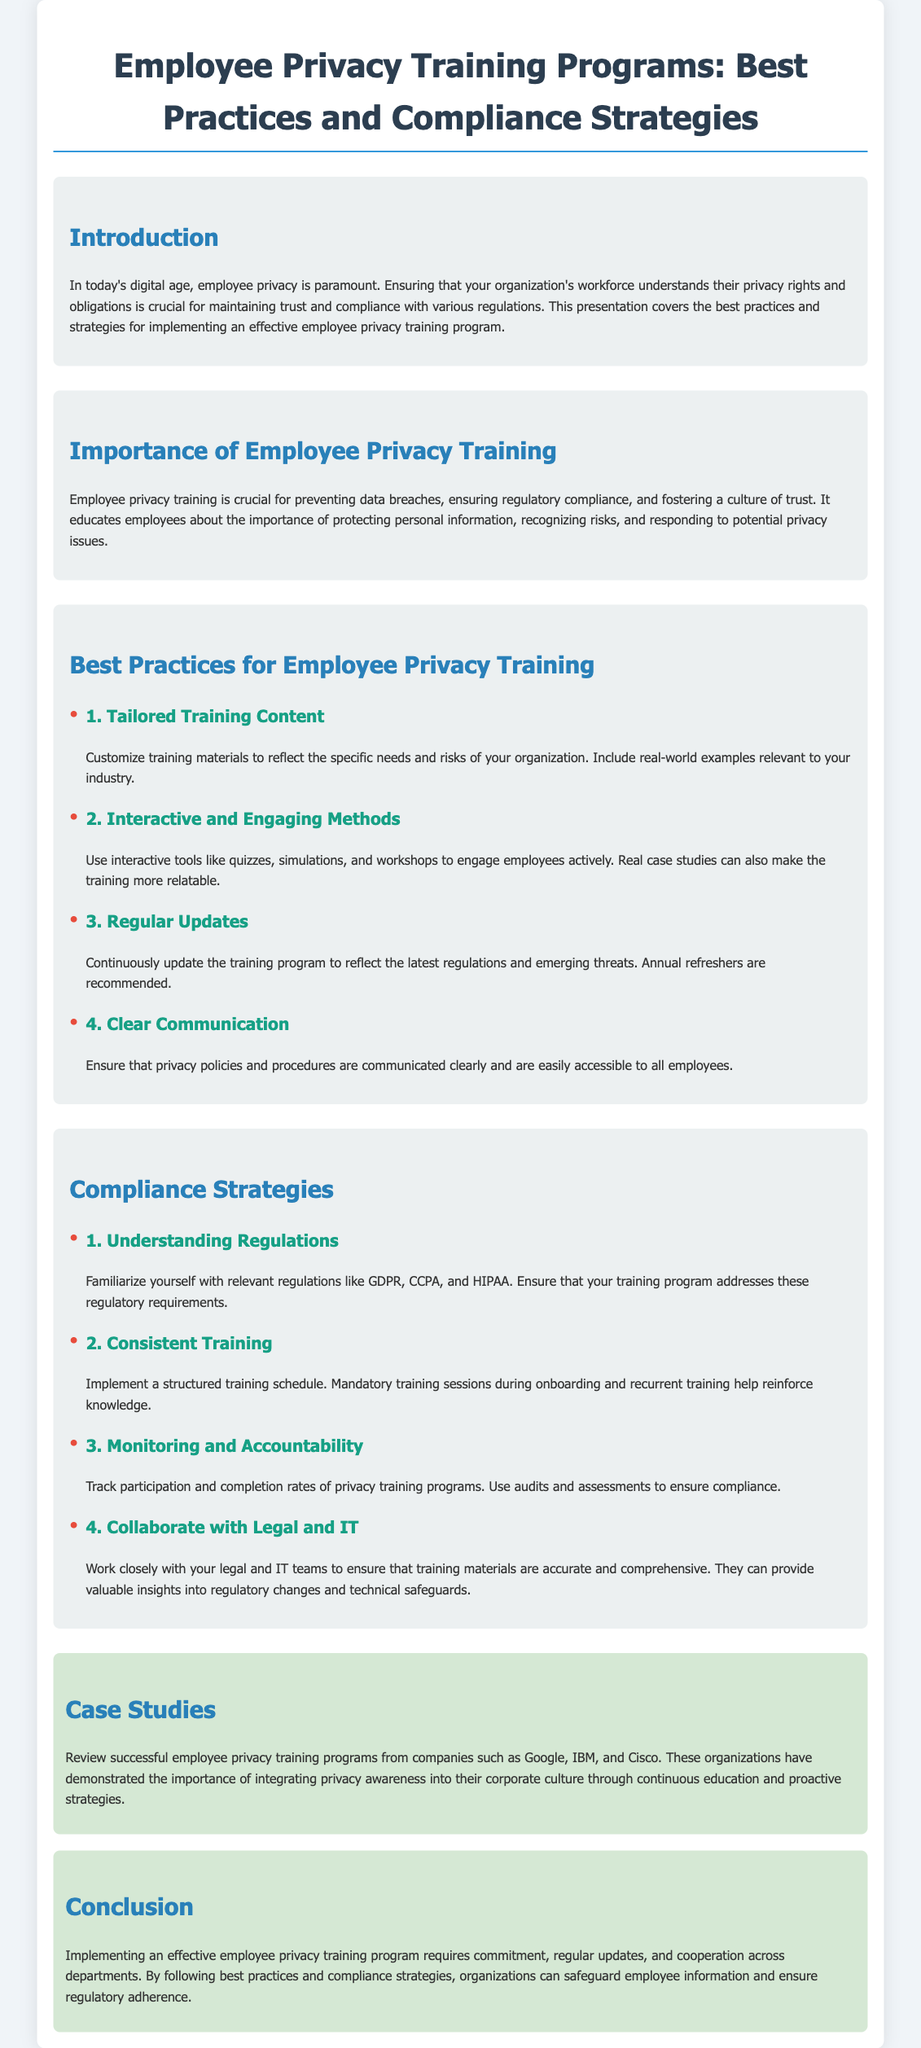What is the main focus of the presentation? The main focus of the presentation is to discuss best practices and compliance strategies for employee privacy training programs.
Answer: Best practices and compliance strategies for employee privacy training programs Why is employee privacy training crucial? Employee privacy training is crucial for preventing data breaches, ensuring regulatory compliance, and fostering a culture of trust.
Answer: Preventing data breaches What type of training methods are suggested? The presentation suggests using interactive tools like quizzes, simulations, and workshops to engage employees actively.
Answer: Interactive tools like quizzes, simulations, and workshops Which regulations should the training program address? The training program should address regulations like GDPR, CCPA, and HIPAA.
Answer: GDPR, CCPA, HIPAA What is recommended as a part of the compliance strategy? A structured training schedule with mandatory training sessions during onboarding and recurrent training is recommended.
Answer: Structured training schedule Which companies are mentioned as case studies? Successful employee privacy training programs were implemented by companies such as Google, IBM, and Cisco.
Answer: Google, IBM, Cisco What is a key requirement for effective training programs? Commitment, regular updates, and cooperation across departments are key requirements for effective training programs.
Answer: Commitment, regular updates, cooperation What does 'Clear Communication' emphasize in training? 'Clear Communication' emphasizes ensuring that privacy policies and procedures are communicated clearly and are easily accessible to all employees.
Answer: Communicated clearly and easily accessible What is the conclusion of the presentation? The conclusion emphasizes that by following best practices and compliance strategies, organizations can safeguard employee information and ensure regulatory adherence.
Answer: Safeguard employee information and ensure regulatory adherence 